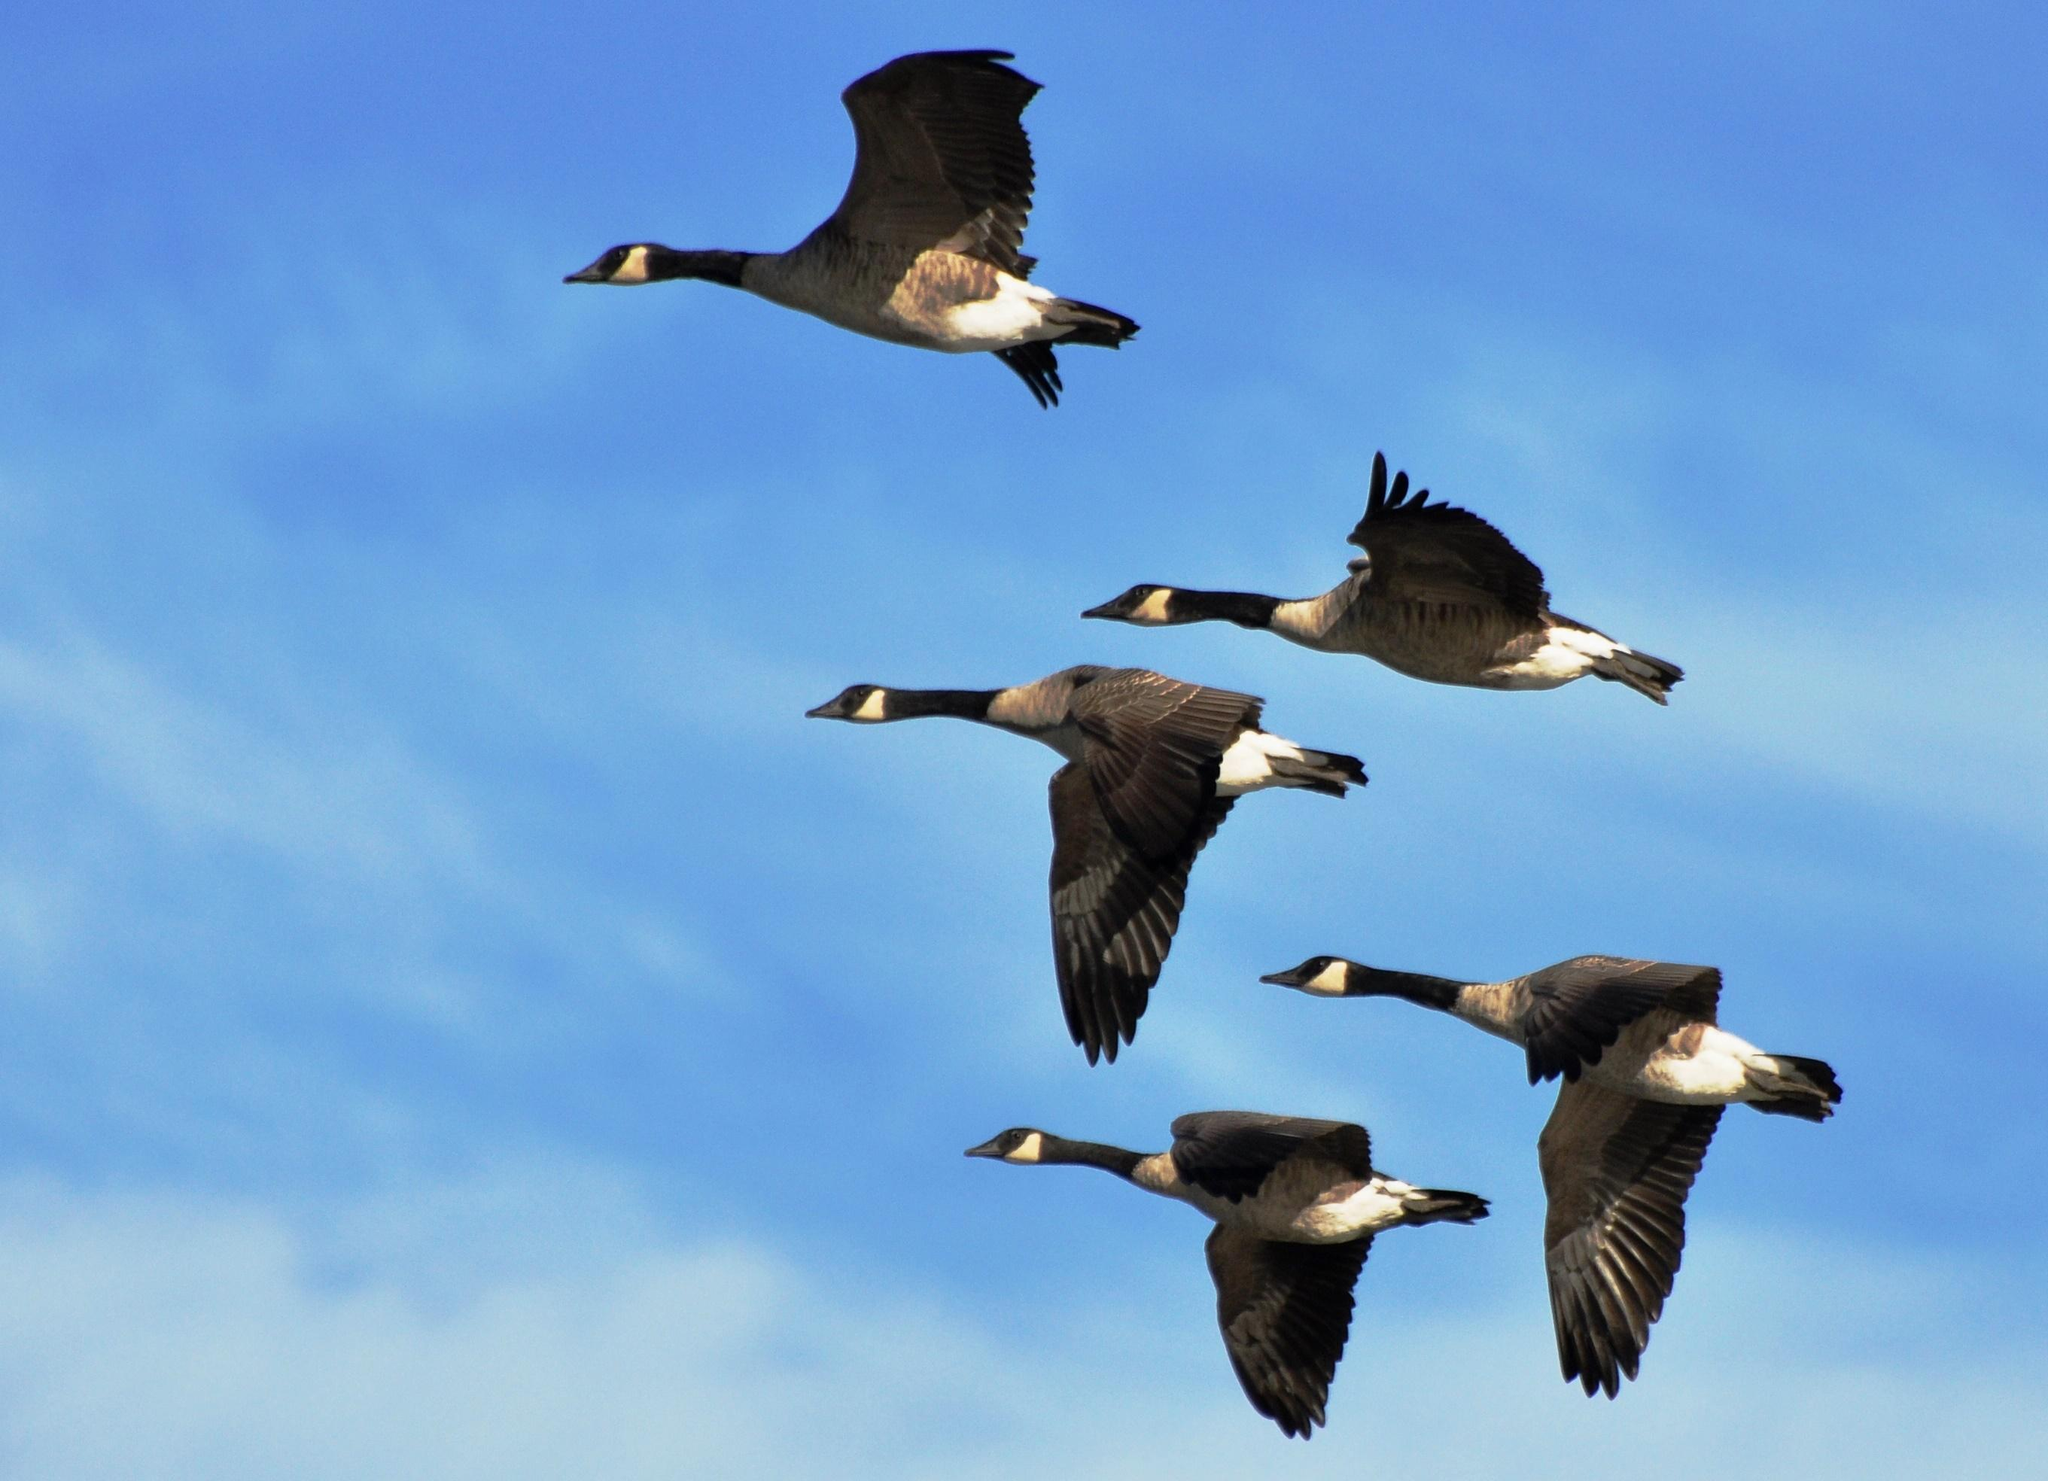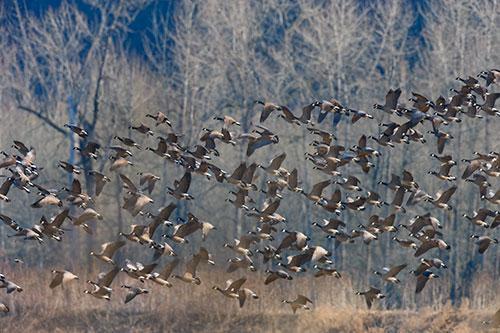The first image is the image on the left, the second image is the image on the right. For the images shown, is this caption "There are no more than 22 birds in one of the images." true? Answer yes or no. Yes. The first image is the image on the left, the second image is the image on the right. For the images displayed, is the sentence "In one image, only birds and sky are visible." factually correct? Answer yes or no. Yes. 